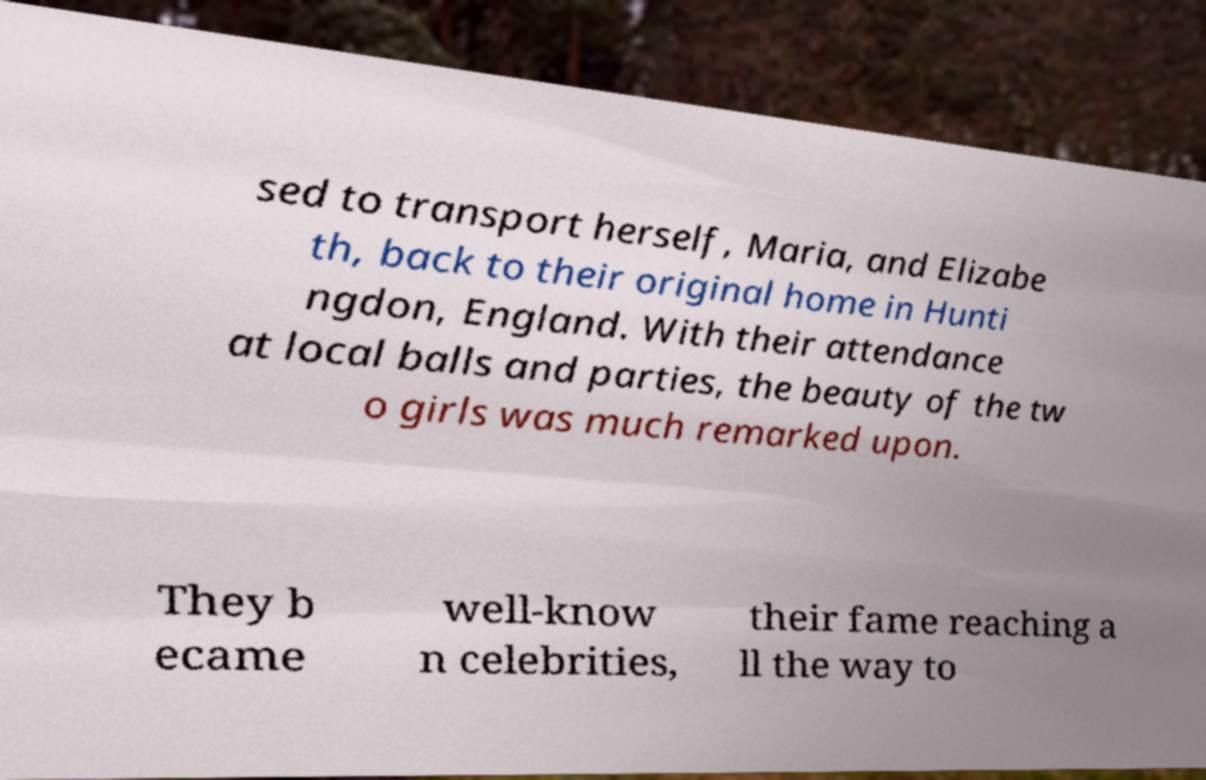Can you accurately transcribe the text from the provided image for me? sed to transport herself, Maria, and Elizabe th, back to their original home in Hunti ngdon, England. With their attendance at local balls and parties, the beauty of the tw o girls was much remarked upon. They b ecame well-know n celebrities, their fame reaching a ll the way to 